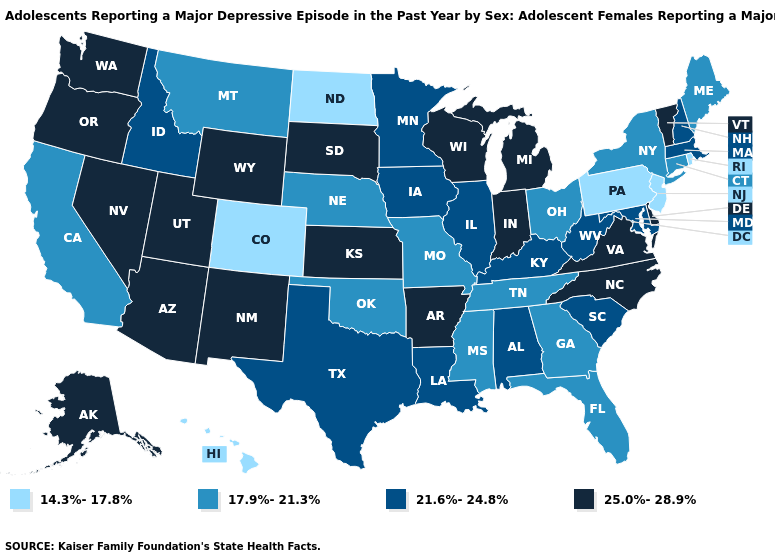Name the states that have a value in the range 25.0%-28.9%?
Give a very brief answer. Alaska, Arizona, Arkansas, Delaware, Indiana, Kansas, Michigan, Nevada, New Mexico, North Carolina, Oregon, South Dakota, Utah, Vermont, Virginia, Washington, Wisconsin, Wyoming. What is the lowest value in the Northeast?
Short answer required. 14.3%-17.8%. Does Delaware have the lowest value in the USA?
Concise answer only. No. Name the states that have a value in the range 14.3%-17.8%?
Be succinct. Colorado, Hawaii, New Jersey, North Dakota, Pennsylvania, Rhode Island. What is the highest value in the South ?
Be succinct. 25.0%-28.9%. What is the value of Oklahoma?
Concise answer only. 17.9%-21.3%. Name the states that have a value in the range 17.9%-21.3%?
Answer briefly. California, Connecticut, Florida, Georgia, Maine, Mississippi, Missouri, Montana, Nebraska, New York, Ohio, Oklahoma, Tennessee. Does Indiana have the highest value in the USA?
Keep it brief. Yes. Which states have the lowest value in the USA?
Concise answer only. Colorado, Hawaii, New Jersey, North Dakota, Pennsylvania, Rhode Island. Name the states that have a value in the range 25.0%-28.9%?
Quick response, please. Alaska, Arizona, Arkansas, Delaware, Indiana, Kansas, Michigan, Nevada, New Mexico, North Carolina, Oregon, South Dakota, Utah, Vermont, Virginia, Washington, Wisconsin, Wyoming. What is the value of Georgia?
Concise answer only. 17.9%-21.3%. What is the highest value in the Northeast ?
Concise answer only. 25.0%-28.9%. What is the value of Louisiana?
Give a very brief answer. 21.6%-24.8%. What is the highest value in states that border Rhode Island?
Answer briefly. 21.6%-24.8%. Name the states that have a value in the range 17.9%-21.3%?
Quick response, please. California, Connecticut, Florida, Georgia, Maine, Mississippi, Missouri, Montana, Nebraska, New York, Ohio, Oklahoma, Tennessee. 